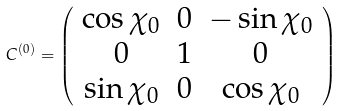<formula> <loc_0><loc_0><loc_500><loc_500>C ^ { ( 0 ) } = \left ( \begin{array} { c c c } \cos { \chi _ { 0 } } & 0 & - \sin { \chi _ { 0 } } \\ 0 & 1 & 0 \\ \sin { \chi _ { 0 } } & 0 & \cos { \chi _ { 0 } } \end{array} \right )</formula> 